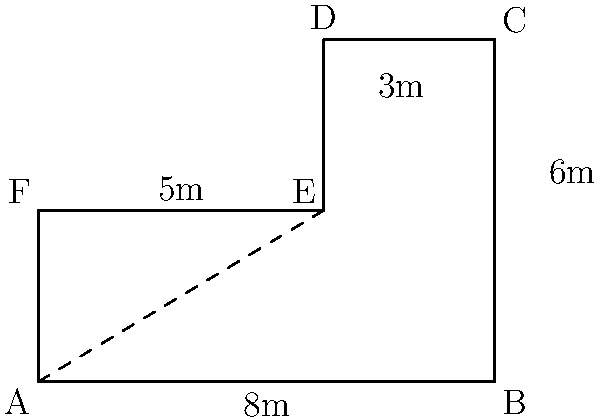In designing an efficient office floor plan, you're working with a hexagonal space ABCDEF as shown in the diagram. To optimize workflow, you need to calculate the total floor area. What is the area of this office space in square meters? To calculate the area of the hexagonal office space, we can break it down into simpler shapes:

1. First, divide the hexagon into a rectangle (ABEF) and a right-angled trapezoid (BCDE).

2. Calculate the area of the rectangle ABEF:
   Area of rectangle = length × width
   $A_{rectangle} = 8m × 3m = 24m^2$

3. Calculate the area of the right-angled trapezoid BCDE:
   Area of trapezoid = $\frac{1}{2}(a+b)h$, where a and b are parallel sides and h is the height
   $A_{trapezoid} = \frac{1}{2}(8m + 5m) × 3m = \frac{1}{2}(13m) × 3m = 19.5m^2$

4. Sum up the areas:
   Total Area = Area of rectangle + Area of trapezoid
   $A_{total} = 24m^2 + 19.5m^2 = 43.5m^2$

Therefore, the total area of the office space is 43.5 square meters.
Answer: $43.5m^2$ 